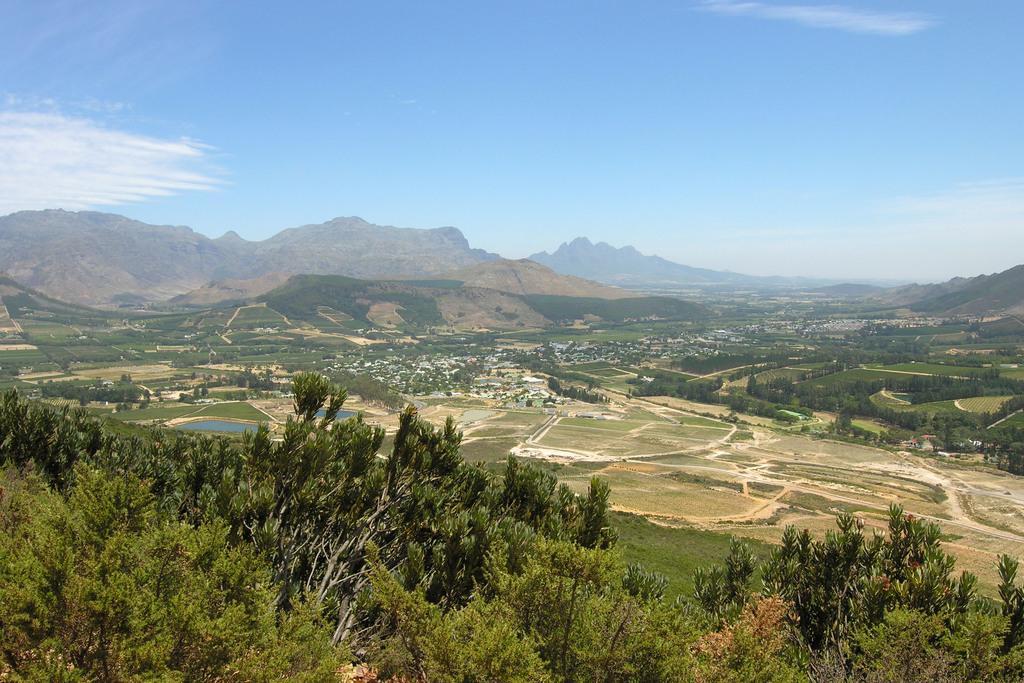Can you describe this image briefly? In this image, I can see the trees. These are the hills. I think here is the water. I can see the clouds in the sky. I think these are the houses. 